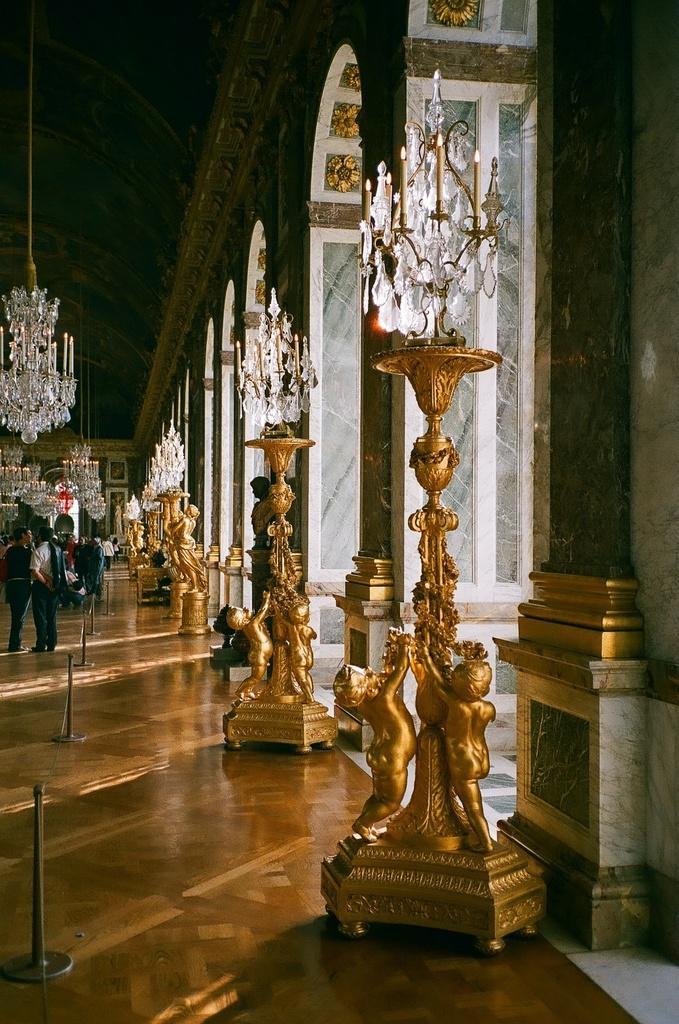In one or two sentences, can you explain what this image depicts? In this picture we can see many floor lamp light chandeliers placed on the ground. 